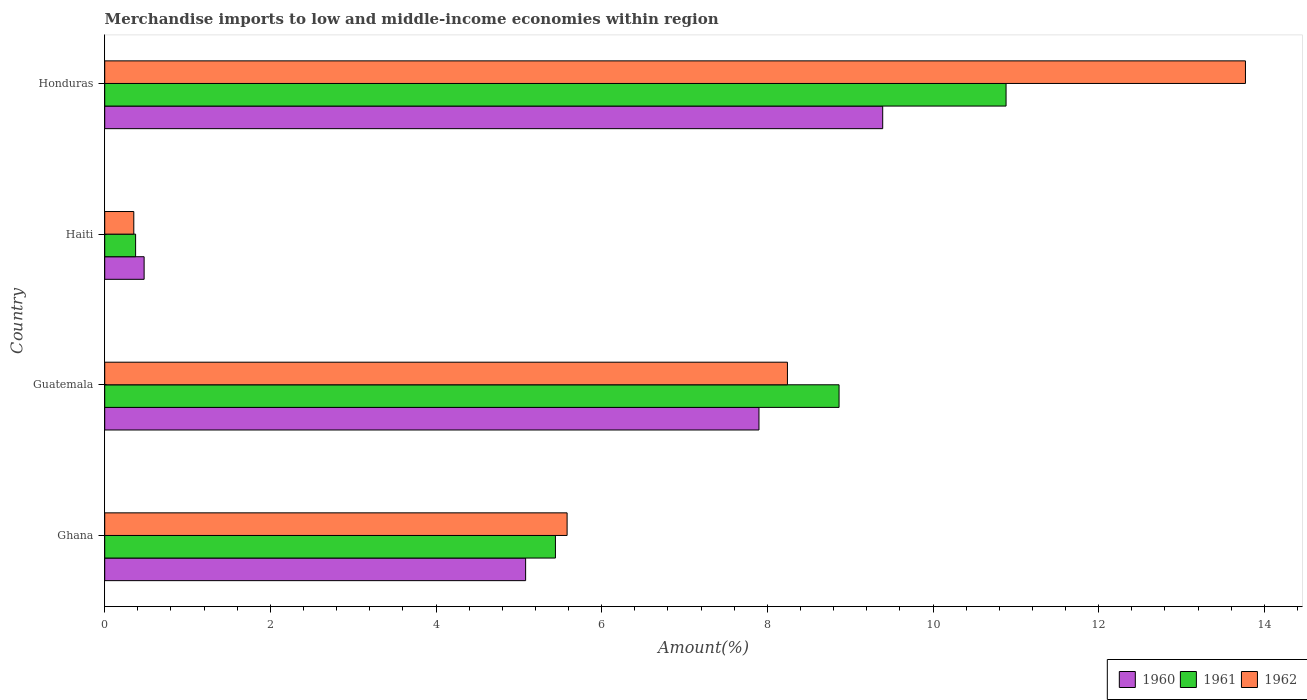How many different coloured bars are there?
Your answer should be compact. 3. How many groups of bars are there?
Ensure brevity in your answer.  4. Are the number of bars per tick equal to the number of legend labels?
Provide a succinct answer. Yes. Are the number of bars on each tick of the Y-axis equal?
Offer a terse response. Yes. How many bars are there on the 4th tick from the top?
Your response must be concise. 3. In how many cases, is the number of bars for a given country not equal to the number of legend labels?
Provide a short and direct response. 0. What is the percentage of amount earned from merchandise imports in 1960 in Ghana?
Provide a short and direct response. 5.08. Across all countries, what is the maximum percentage of amount earned from merchandise imports in 1961?
Your response must be concise. 10.88. Across all countries, what is the minimum percentage of amount earned from merchandise imports in 1962?
Provide a succinct answer. 0.35. In which country was the percentage of amount earned from merchandise imports in 1960 maximum?
Ensure brevity in your answer.  Honduras. In which country was the percentage of amount earned from merchandise imports in 1961 minimum?
Offer a very short reply. Haiti. What is the total percentage of amount earned from merchandise imports in 1961 in the graph?
Provide a short and direct response. 25.56. What is the difference between the percentage of amount earned from merchandise imports in 1962 in Guatemala and that in Haiti?
Your response must be concise. 7.89. What is the difference between the percentage of amount earned from merchandise imports in 1962 in Ghana and the percentage of amount earned from merchandise imports in 1960 in Haiti?
Keep it short and to the point. 5.11. What is the average percentage of amount earned from merchandise imports in 1962 per country?
Provide a succinct answer. 6.99. What is the difference between the percentage of amount earned from merchandise imports in 1960 and percentage of amount earned from merchandise imports in 1962 in Haiti?
Give a very brief answer. 0.12. What is the ratio of the percentage of amount earned from merchandise imports in 1962 in Ghana to that in Guatemala?
Offer a terse response. 0.68. Is the percentage of amount earned from merchandise imports in 1962 in Haiti less than that in Honduras?
Provide a succinct answer. Yes. What is the difference between the highest and the second highest percentage of amount earned from merchandise imports in 1960?
Your response must be concise. 1.49. What is the difference between the highest and the lowest percentage of amount earned from merchandise imports in 1962?
Keep it short and to the point. 13.42. What does the 1st bar from the top in Honduras represents?
Your answer should be very brief. 1962. What does the 3rd bar from the bottom in Guatemala represents?
Ensure brevity in your answer.  1962. How many bars are there?
Offer a very short reply. 12. Are all the bars in the graph horizontal?
Provide a short and direct response. Yes. What is the difference between two consecutive major ticks on the X-axis?
Your response must be concise. 2. Are the values on the major ticks of X-axis written in scientific E-notation?
Offer a very short reply. No. Where does the legend appear in the graph?
Make the answer very short. Bottom right. How many legend labels are there?
Offer a terse response. 3. How are the legend labels stacked?
Offer a very short reply. Horizontal. What is the title of the graph?
Make the answer very short. Merchandise imports to low and middle-income economies within region. Does "1983" appear as one of the legend labels in the graph?
Your answer should be compact. No. What is the label or title of the X-axis?
Offer a very short reply. Amount(%). What is the Amount(%) of 1960 in Ghana?
Your answer should be very brief. 5.08. What is the Amount(%) of 1961 in Ghana?
Offer a terse response. 5.44. What is the Amount(%) in 1962 in Ghana?
Offer a very short reply. 5.58. What is the Amount(%) of 1960 in Guatemala?
Give a very brief answer. 7.9. What is the Amount(%) in 1961 in Guatemala?
Offer a very short reply. 8.87. What is the Amount(%) in 1962 in Guatemala?
Offer a very short reply. 8.24. What is the Amount(%) in 1960 in Haiti?
Make the answer very short. 0.48. What is the Amount(%) of 1961 in Haiti?
Make the answer very short. 0.37. What is the Amount(%) in 1962 in Haiti?
Your response must be concise. 0.35. What is the Amount(%) in 1960 in Honduras?
Your answer should be compact. 9.39. What is the Amount(%) in 1961 in Honduras?
Keep it short and to the point. 10.88. What is the Amount(%) of 1962 in Honduras?
Offer a terse response. 13.77. Across all countries, what is the maximum Amount(%) of 1960?
Keep it short and to the point. 9.39. Across all countries, what is the maximum Amount(%) in 1961?
Your answer should be very brief. 10.88. Across all countries, what is the maximum Amount(%) of 1962?
Your response must be concise. 13.77. Across all countries, what is the minimum Amount(%) of 1960?
Make the answer very short. 0.48. Across all countries, what is the minimum Amount(%) of 1961?
Your answer should be very brief. 0.37. Across all countries, what is the minimum Amount(%) in 1962?
Ensure brevity in your answer.  0.35. What is the total Amount(%) in 1960 in the graph?
Provide a short and direct response. 22.85. What is the total Amount(%) of 1961 in the graph?
Give a very brief answer. 25.56. What is the total Amount(%) in 1962 in the graph?
Offer a terse response. 27.95. What is the difference between the Amount(%) in 1960 in Ghana and that in Guatemala?
Offer a terse response. -2.82. What is the difference between the Amount(%) of 1961 in Ghana and that in Guatemala?
Your answer should be very brief. -3.42. What is the difference between the Amount(%) in 1962 in Ghana and that in Guatemala?
Offer a terse response. -2.66. What is the difference between the Amount(%) in 1960 in Ghana and that in Haiti?
Provide a short and direct response. 4.61. What is the difference between the Amount(%) of 1961 in Ghana and that in Haiti?
Ensure brevity in your answer.  5.07. What is the difference between the Amount(%) of 1962 in Ghana and that in Haiti?
Your answer should be very brief. 5.23. What is the difference between the Amount(%) in 1960 in Ghana and that in Honduras?
Provide a short and direct response. -4.31. What is the difference between the Amount(%) of 1961 in Ghana and that in Honduras?
Ensure brevity in your answer.  -5.44. What is the difference between the Amount(%) in 1962 in Ghana and that in Honduras?
Provide a short and direct response. -8.19. What is the difference between the Amount(%) of 1960 in Guatemala and that in Haiti?
Give a very brief answer. 7.42. What is the difference between the Amount(%) in 1961 in Guatemala and that in Haiti?
Provide a succinct answer. 8.49. What is the difference between the Amount(%) in 1962 in Guatemala and that in Haiti?
Provide a short and direct response. 7.89. What is the difference between the Amount(%) in 1960 in Guatemala and that in Honduras?
Keep it short and to the point. -1.49. What is the difference between the Amount(%) in 1961 in Guatemala and that in Honduras?
Your answer should be very brief. -2.02. What is the difference between the Amount(%) of 1962 in Guatemala and that in Honduras?
Your answer should be very brief. -5.53. What is the difference between the Amount(%) of 1960 in Haiti and that in Honduras?
Offer a terse response. -8.92. What is the difference between the Amount(%) in 1961 in Haiti and that in Honduras?
Give a very brief answer. -10.51. What is the difference between the Amount(%) of 1962 in Haiti and that in Honduras?
Make the answer very short. -13.42. What is the difference between the Amount(%) in 1960 in Ghana and the Amount(%) in 1961 in Guatemala?
Provide a short and direct response. -3.78. What is the difference between the Amount(%) in 1960 in Ghana and the Amount(%) in 1962 in Guatemala?
Ensure brevity in your answer.  -3.16. What is the difference between the Amount(%) in 1961 in Ghana and the Amount(%) in 1962 in Guatemala?
Your answer should be very brief. -2.8. What is the difference between the Amount(%) in 1960 in Ghana and the Amount(%) in 1961 in Haiti?
Ensure brevity in your answer.  4.71. What is the difference between the Amount(%) of 1960 in Ghana and the Amount(%) of 1962 in Haiti?
Give a very brief answer. 4.73. What is the difference between the Amount(%) in 1961 in Ghana and the Amount(%) in 1962 in Haiti?
Provide a short and direct response. 5.09. What is the difference between the Amount(%) in 1960 in Ghana and the Amount(%) in 1961 in Honduras?
Your answer should be compact. -5.8. What is the difference between the Amount(%) of 1960 in Ghana and the Amount(%) of 1962 in Honduras?
Provide a succinct answer. -8.69. What is the difference between the Amount(%) of 1961 in Ghana and the Amount(%) of 1962 in Honduras?
Keep it short and to the point. -8.33. What is the difference between the Amount(%) in 1960 in Guatemala and the Amount(%) in 1961 in Haiti?
Provide a succinct answer. 7.53. What is the difference between the Amount(%) of 1960 in Guatemala and the Amount(%) of 1962 in Haiti?
Your response must be concise. 7.55. What is the difference between the Amount(%) in 1961 in Guatemala and the Amount(%) in 1962 in Haiti?
Make the answer very short. 8.51. What is the difference between the Amount(%) of 1960 in Guatemala and the Amount(%) of 1961 in Honduras?
Your answer should be compact. -2.98. What is the difference between the Amount(%) of 1960 in Guatemala and the Amount(%) of 1962 in Honduras?
Offer a very short reply. -5.87. What is the difference between the Amount(%) of 1961 in Guatemala and the Amount(%) of 1962 in Honduras?
Give a very brief answer. -4.91. What is the difference between the Amount(%) in 1960 in Haiti and the Amount(%) in 1961 in Honduras?
Keep it short and to the point. -10.41. What is the difference between the Amount(%) of 1960 in Haiti and the Amount(%) of 1962 in Honduras?
Your answer should be very brief. -13.3. What is the difference between the Amount(%) in 1961 in Haiti and the Amount(%) in 1962 in Honduras?
Your answer should be very brief. -13.4. What is the average Amount(%) of 1960 per country?
Provide a short and direct response. 5.71. What is the average Amount(%) of 1961 per country?
Your answer should be compact. 6.39. What is the average Amount(%) in 1962 per country?
Offer a terse response. 6.99. What is the difference between the Amount(%) of 1960 and Amount(%) of 1961 in Ghana?
Make the answer very short. -0.36. What is the difference between the Amount(%) of 1960 and Amount(%) of 1962 in Ghana?
Provide a short and direct response. -0.5. What is the difference between the Amount(%) of 1961 and Amount(%) of 1962 in Ghana?
Offer a very short reply. -0.14. What is the difference between the Amount(%) of 1960 and Amount(%) of 1961 in Guatemala?
Provide a short and direct response. -0.97. What is the difference between the Amount(%) in 1960 and Amount(%) in 1962 in Guatemala?
Ensure brevity in your answer.  -0.34. What is the difference between the Amount(%) in 1961 and Amount(%) in 1962 in Guatemala?
Make the answer very short. 0.62. What is the difference between the Amount(%) of 1960 and Amount(%) of 1961 in Haiti?
Keep it short and to the point. 0.1. What is the difference between the Amount(%) of 1960 and Amount(%) of 1962 in Haiti?
Keep it short and to the point. 0.12. What is the difference between the Amount(%) of 1961 and Amount(%) of 1962 in Haiti?
Offer a very short reply. 0.02. What is the difference between the Amount(%) of 1960 and Amount(%) of 1961 in Honduras?
Provide a succinct answer. -1.49. What is the difference between the Amount(%) in 1960 and Amount(%) in 1962 in Honduras?
Make the answer very short. -4.38. What is the difference between the Amount(%) in 1961 and Amount(%) in 1962 in Honduras?
Keep it short and to the point. -2.89. What is the ratio of the Amount(%) of 1960 in Ghana to that in Guatemala?
Your answer should be very brief. 0.64. What is the ratio of the Amount(%) in 1961 in Ghana to that in Guatemala?
Make the answer very short. 0.61. What is the ratio of the Amount(%) of 1962 in Ghana to that in Guatemala?
Provide a succinct answer. 0.68. What is the ratio of the Amount(%) in 1960 in Ghana to that in Haiti?
Offer a terse response. 10.68. What is the ratio of the Amount(%) of 1961 in Ghana to that in Haiti?
Offer a very short reply. 14.59. What is the ratio of the Amount(%) of 1962 in Ghana to that in Haiti?
Keep it short and to the point. 15.9. What is the ratio of the Amount(%) in 1960 in Ghana to that in Honduras?
Make the answer very short. 0.54. What is the ratio of the Amount(%) in 1961 in Ghana to that in Honduras?
Offer a terse response. 0.5. What is the ratio of the Amount(%) in 1962 in Ghana to that in Honduras?
Give a very brief answer. 0.41. What is the ratio of the Amount(%) of 1960 in Guatemala to that in Haiti?
Provide a short and direct response. 16.61. What is the ratio of the Amount(%) of 1961 in Guatemala to that in Haiti?
Offer a terse response. 23.77. What is the ratio of the Amount(%) in 1962 in Guatemala to that in Haiti?
Offer a very short reply. 23.47. What is the ratio of the Amount(%) in 1960 in Guatemala to that in Honduras?
Ensure brevity in your answer.  0.84. What is the ratio of the Amount(%) in 1961 in Guatemala to that in Honduras?
Your response must be concise. 0.81. What is the ratio of the Amount(%) of 1962 in Guatemala to that in Honduras?
Your answer should be compact. 0.6. What is the ratio of the Amount(%) in 1960 in Haiti to that in Honduras?
Provide a succinct answer. 0.05. What is the ratio of the Amount(%) in 1961 in Haiti to that in Honduras?
Ensure brevity in your answer.  0.03. What is the ratio of the Amount(%) in 1962 in Haiti to that in Honduras?
Make the answer very short. 0.03. What is the difference between the highest and the second highest Amount(%) in 1960?
Ensure brevity in your answer.  1.49. What is the difference between the highest and the second highest Amount(%) in 1961?
Provide a short and direct response. 2.02. What is the difference between the highest and the second highest Amount(%) in 1962?
Offer a terse response. 5.53. What is the difference between the highest and the lowest Amount(%) in 1960?
Provide a short and direct response. 8.92. What is the difference between the highest and the lowest Amount(%) of 1961?
Your response must be concise. 10.51. What is the difference between the highest and the lowest Amount(%) of 1962?
Keep it short and to the point. 13.42. 